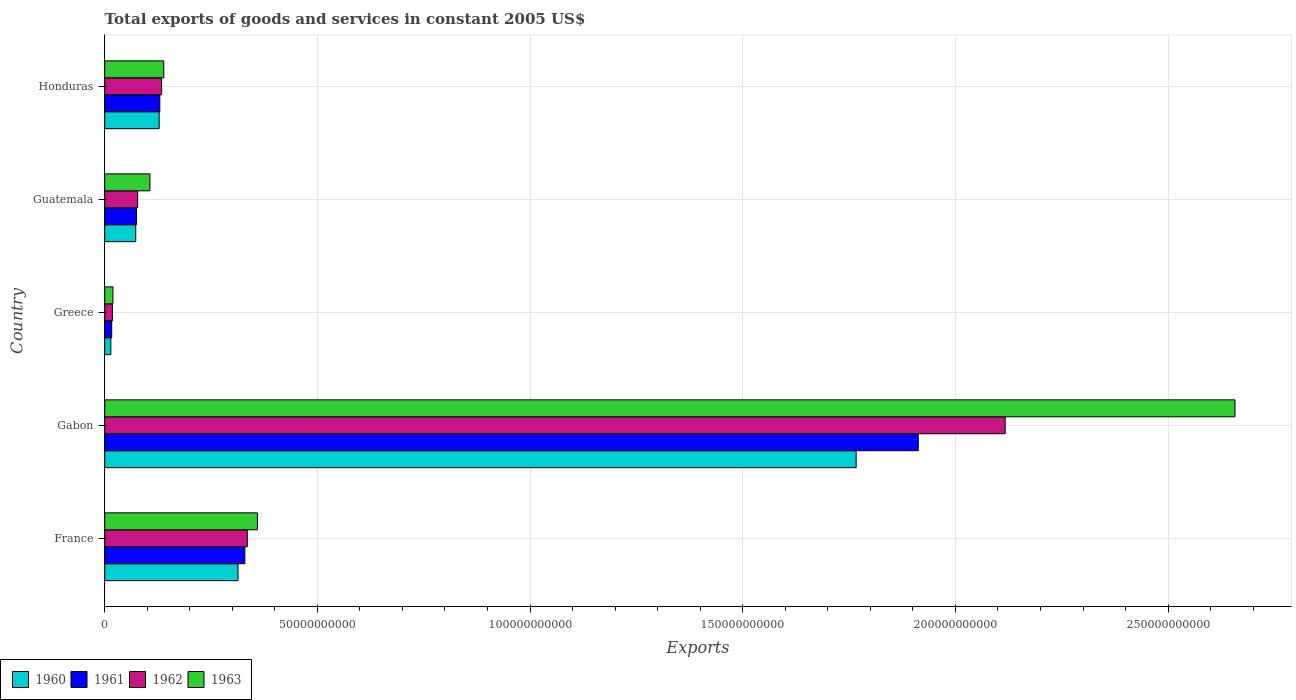Are the number of bars per tick equal to the number of legend labels?
Your response must be concise. Yes. What is the label of the 1st group of bars from the top?
Your answer should be very brief. Honduras. What is the total exports of goods and services in 1961 in France?
Keep it short and to the point. 3.29e+1. Across all countries, what is the maximum total exports of goods and services in 1960?
Offer a very short reply. 1.77e+11. Across all countries, what is the minimum total exports of goods and services in 1962?
Give a very brief answer. 1.81e+09. In which country was the total exports of goods and services in 1963 maximum?
Your answer should be compact. Gabon. What is the total total exports of goods and services in 1962 in the graph?
Provide a short and direct response. 2.68e+11. What is the difference between the total exports of goods and services in 1962 in Greece and that in Guatemala?
Your response must be concise. -5.94e+09. What is the difference between the total exports of goods and services in 1960 in Guatemala and the total exports of goods and services in 1961 in Gabon?
Offer a terse response. -1.84e+11. What is the average total exports of goods and services in 1962 per country?
Your response must be concise. 5.36e+1. What is the difference between the total exports of goods and services in 1962 and total exports of goods and services in 1960 in France?
Provide a short and direct response. 2.19e+09. What is the ratio of the total exports of goods and services in 1963 in Guatemala to that in Honduras?
Your response must be concise. 0.76. What is the difference between the highest and the second highest total exports of goods and services in 1960?
Ensure brevity in your answer.  1.45e+11. What is the difference between the highest and the lowest total exports of goods and services in 1961?
Your answer should be compact. 1.90e+11. In how many countries, is the total exports of goods and services in 1962 greater than the average total exports of goods and services in 1962 taken over all countries?
Offer a very short reply. 1. Is it the case that in every country, the sum of the total exports of goods and services in 1962 and total exports of goods and services in 1963 is greater than the sum of total exports of goods and services in 1961 and total exports of goods and services in 1960?
Ensure brevity in your answer.  No. Is it the case that in every country, the sum of the total exports of goods and services in 1961 and total exports of goods and services in 1963 is greater than the total exports of goods and services in 1960?
Provide a short and direct response. Yes. How many bars are there?
Offer a terse response. 20. Are all the bars in the graph horizontal?
Your answer should be compact. Yes. How many countries are there in the graph?
Provide a succinct answer. 5. What is the difference between two consecutive major ticks on the X-axis?
Make the answer very short. 5.00e+1. Are the values on the major ticks of X-axis written in scientific E-notation?
Your answer should be very brief. No. Does the graph contain grids?
Ensure brevity in your answer.  Yes. How are the legend labels stacked?
Your response must be concise. Horizontal. What is the title of the graph?
Your answer should be compact. Total exports of goods and services in constant 2005 US$. What is the label or title of the X-axis?
Your answer should be very brief. Exports. What is the label or title of the Y-axis?
Give a very brief answer. Country. What is the Exports of 1960 in France?
Ensure brevity in your answer.  3.13e+1. What is the Exports of 1961 in France?
Offer a terse response. 3.29e+1. What is the Exports in 1962 in France?
Provide a succinct answer. 3.35e+1. What is the Exports of 1963 in France?
Your response must be concise. 3.59e+1. What is the Exports in 1960 in Gabon?
Offer a very short reply. 1.77e+11. What is the Exports of 1961 in Gabon?
Ensure brevity in your answer.  1.91e+11. What is the Exports in 1962 in Gabon?
Your response must be concise. 2.12e+11. What is the Exports in 1963 in Gabon?
Your response must be concise. 2.66e+11. What is the Exports in 1960 in Greece?
Ensure brevity in your answer.  1.43e+09. What is the Exports in 1961 in Greece?
Provide a short and direct response. 1.64e+09. What is the Exports of 1962 in Greece?
Give a very brief answer. 1.81e+09. What is the Exports of 1963 in Greece?
Provide a succinct answer. 1.93e+09. What is the Exports in 1960 in Guatemala?
Your response must be concise. 7.29e+09. What is the Exports of 1961 in Guatemala?
Make the answer very short. 7.46e+09. What is the Exports of 1962 in Guatemala?
Provide a short and direct response. 7.75e+09. What is the Exports in 1963 in Guatemala?
Provide a succinct answer. 1.06e+1. What is the Exports in 1960 in Honduras?
Offer a very short reply. 1.28e+1. What is the Exports of 1961 in Honduras?
Your answer should be very brief. 1.30e+1. What is the Exports of 1962 in Honduras?
Make the answer very short. 1.34e+1. What is the Exports in 1963 in Honduras?
Your response must be concise. 1.39e+1. Across all countries, what is the maximum Exports of 1960?
Your answer should be compact. 1.77e+11. Across all countries, what is the maximum Exports in 1961?
Offer a very short reply. 1.91e+11. Across all countries, what is the maximum Exports in 1962?
Your response must be concise. 2.12e+11. Across all countries, what is the maximum Exports in 1963?
Provide a succinct answer. 2.66e+11. Across all countries, what is the minimum Exports of 1960?
Offer a terse response. 1.43e+09. Across all countries, what is the minimum Exports of 1961?
Provide a succinct answer. 1.64e+09. Across all countries, what is the minimum Exports in 1962?
Give a very brief answer. 1.81e+09. Across all countries, what is the minimum Exports in 1963?
Offer a very short reply. 1.93e+09. What is the total Exports in 1960 in the graph?
Keep it short and to the point. 2.30e+11. What is the total Exports of 1961 in the graph?
Your answer should be very brief. 2.46e+11. What is the total Exports of 1962 in the graph?
Your answer should be compact. 2.68e+11. What is the total Exports of 1963 in the graph?
Offer a terse response. 3.28e+11. What is the difference between the Exports in 1960 in France and that in Gabon?
Make the answer very short. -1.45e+11. What is the difference between the Exports in 1961 in France and that in Gabon?
Keep it short and to the point. -1.58e+11. What is the difference between the Exports of 1962 in France and that in Gabon?
Offer a terse response. -1.78e+11. What is the difference between the Exports in 1963 in France and that in Gabon?
Make the answer very short. -2.30e+11. What is the difference between the Exports of 1960 in France and that in Greece?
Provide a succinct answer. 2.99e+1. What is the difference between the Exports in 1961 in France and that in Greece?
Make the answer very short. 3.13e+1. What is the difference between the Exports in 1962 in France and that in Greece?
Provide a short and direct response. 3.17e+1. What is the difference between the Exports in 1963 in France and that in Greece?
Provide a short and direct response. 3.40e+1. What is the difference between the Exports in 1960 in France and that in Guatemala?
Provide a succinct answer. 2.40e+1. What is the difference between the Exports in 1961 in France and that in Guatemala?
Make the answer very short. 2.55e+1. What is the difference between the Exports in 1962 in France and that in Guatemala?
Offer a terse response. 2.58e+1. What is the difference between the Exports in 1963 in France and that in Guatemala?
Provide a short and direct response. 2.53e+1. What is the difference between the Exports in 1960 in France and that in Honduras?
Your response must be concise. 1.85e+1. What is the difference between the Exports in 1961 in France and that in Honduras?
Ensure brevity in your answer.  2.00e+1. What is the difference between the Exports of 1962 in France and that in Honduras?
Provide a short and direct response. 2.01e+1. What is the difference between the Exports of 1963 in France and that in Honduras?
Your answer should be very brief. 2.20e+1. What is the difference between the Exports of 1960 in Gabon and that in Greece?
Your answer should be very brief. 1.75e+11. What is the difference between the Exports of 1961 in Gabon and that in Greece?
Offer a terse response. 1.90e+11. What is the difference between the Exports in 1962 in Gabon and that in Greece?
Your answer should be very brief. 2.10e+11. What is the difference between the Exports in 1963 in Gabon and that in Greece?
Offer a terse response. 2.64e+11. What is the difference between the Exports of 1960 in Gabon and that in Guatemala?
Make the answer very short. 1.69e+11. What is the difference between the Exports in 1961 in Gabon and that in Guatemala?
Give a very brief answer. 1.84e+11. What is the difference between the Exports of 1962 in Gabon and that in Guatemala?
Your answer should be compact. 2.04e+11. What is the difference between the Exports of 1963 in Gabon and that in Guatemala?
Offer a terse response. 2.55e+11. What is the difference between the Exports of 1960 in Gabon and that in Honduras?
Make the answer very short. 1.64e+11. What is the difference between the Exports of 1961 in Gabon and that in Honduras?
Give a very brief answer. 1.78e+11. What is the difference between the Exports of 1962 in Gabon and that in Honduras?
Give a very brief answer. 1.98e+11. What is the difference between the Exports of 1963 in Gabon and that in Honduras?
Give a very brief answer. 2.52e+11. What is the difference between the Exports of 1960 in Greece and that in Guatemala?
Your answer should be very brief. -5.85e+09. What is the difference between the Exports in 1961 in Greece and that in Guatemala?
Provide a short and direct response. -5.82e+09. What is the difference between the Exports of 1962 in Greece and that in Guatemala?
Offer a terse response. -5.94e+09. What is the difference between the Exports in 1963 in Greece and that in Guatemala?
Your answer should be compact. -8.70e+09. What is the difference between the Exports of 1960 in Greece and that in Honduras?
Provide a succinct answer. -1.14e+1. What is the difference between the Exports in 1961 in Greece and that in Honduras?
Keep it short and to the point. -1.13e+1. What is the difference between the Exports of 1962 in Greece and that in Honduras?
Offer a very short reply. -1.16e+1. What is the difference between the Exports of 1963 in Greece and that in Honduras?
Keep it short and to the point. -1.20e+1. What is the difference between the Exports of 1960 in Guatemala and that in Honduras?
Provide a short and direct response. -5.51e+09. What is the difference between the Exports of 1961 in Guatemala and that in Honduras?
Your answer should be compact. -5.49e+09. What is the difference between the Exports of 1962 in Guatemala and that in Honduras?
Your response must be concise. -5.63e+09. What is the difference between the Exports in 1963 in Guatemala and that in Honduras?
Keep it short and to the point. -3.26e+09. What is the difference between the Exports in 1960 in France and the Exports in 1961 in Gabon?
Offer a very short reply. -1.60e+11. What is the difference between the Exports of 1960 in France and the Exports of 1962 in Gabon?
Provide a short and direct response. -1.80e+11. What is the difference between the Exports in 1960 in France and the Exports in 1963 in Gabon?
Provide a short and direct response. -2.34e+11. What is the difference between the Exports of 1961 in France and the Exports of 1962 in Gabon?
Make the answer very short. -1.79e+11. What is the difference between the Exports of 1961 in France and the Exports of 1963 in Gabon?
Keep it short and to the point. -2.33e+11. What is the difference between the Exports of 1962 in France and the Exports of 1963 in Gabon?
Provide a short and direct response. -2.32e+11. What is the difference between the Exports in 1960 in France and the Exports in 1961 in Greece?
Offer a terse response. 2.97e+1. What is the difference between the Exports in 1960 in France and the Exports in 1962 in Greece?
Offer a terse response. 2.95e+1. What is the difference between the Exports in 1960 in France and the Exports in 1963 in Greece?
Ensure brevity in your answer.  2.94e+1. What is the difference between the Exports in 1961 in France and the Exports in 1962 in Greece?
Give a very brief answer. 3.11e+1. What is the difference between the Exports in 1961 in France and the Exports in 1963 in Greece?
Provide a succinct answer. 3.10e+1. What is the difference between the Exports of 1962 in France and the Exports of 1963 in Greece?
Your answer should be compact. 3.16e+1. What is the difference between the Exports of 1960 in France and the Exports of 1961 in Guatemala?
Your response must be concise. 2.39e+1. What is the difference between the Exports in 1960 in France and the Exports in 1962 in Guatemala?
Keep it short and to the point. 2.36e+1. What is the difference between the Exports in 1960 in France and the Exports in 1963 in Guatemala?
Ensure brevity in your answer.  2.07e+1. What is the difference between the Exports of 1961 in France and the Exports of 1962 in Guatemala?
Keep it short and to the point. 2.52e+1. What is the difference between the Exports in 1961 in France and the Exports in 1963 in Guatemala?
Offer a terse response. 2.23e+1. What is the difference between the Exports in 1962 in France and the Exports in 1963 in Guatemala?
Your response must be concise. 2.29e+1. What is the difference between the Exports of 1960 in France and the Exports of 1961 in Honduras?
Offer a very short reply. 1.84e+1. What is the difference between the Exports in 1960 in France and the Exports in 1962 in Honduras?
Ensure brevity in your answer.  1.80e+1. What is the difference between the Exports of 1960 in France and the Exports of 1963 in Honduras?
Give a very brief answer. 1.74e+1. What is the difference between the Exports of 1961 in France and the Exports of 1962 in Honduras?
Provide a short and direct response. 1.96e+1. What is the difference between the Exports of 1961 in France and the Exports of 1963 in Honduras?
Your answer should be very brief. 1.91e+1. What is the difference between the Exports of 1962 in France and the Exports of 1963 in Honduras?
Ensure brevity in your answer.  1.96e+1. What is the difference between the Exports in 1960 in Gabon and the Exports in 1961 in Greece?
Offer a very short reply. 1.75e+11. What is the difference between the Exports in 1960 in Gabon and the Exports in 1962 in Greece?
Make the answer very short. 1.75e+11. What is the difference between the Exports of 1960 in Gabon and the Exports of 1963 in Greece?
Offer a terse response. 1.75e+11. What is the difference between the Exports of 1961 in Gabon and the Exports of 1962 in Greece?
Offer a terse response. 1.89e+11. What is the difference between the Exports of 1961 in Gabon and the Exports of 1963 in Greece?
Keep it short and to the point. 1.89e+11. What is the difference between the Exports of 1962 in Gabon and the Exports of 1963 in Greece?
Keep it short and to the point. 2.10e+11. What is the difference between the Exports of 1960 in Gabon and the Exports of 1961 in Guatemala?
Offer a very short reply. 1.69e+11. What is the difference between the Exports of 1960 in Gabon and the Exports of 1962 in Guatemala?
Make the answer very short. 1.69e+11. What is the difference between the Exports in 1960 in Gabon and the Exports in 1963 in Guatemala?
Give a very brief answer. 1.66e+11. What is the difference between the Exports of 1961 in Gabon and the Exports of 1962 in Guatemala?
Your response must be concise. 1.84e+11. What is the difference between the Exports of 1961 in Gabon and the Exports of 1963 in Guatemala?
Provide a short and direct response. 1.81e+11. What is the difference between the Exports of 1962 in Gabon and the Exports of 1963 in Guatemala?
Give a very brief answer. 2.01e+11. What is the difference between the Exports in 1960 in Gabon and the Exports in 1961 in Honduras?
Your response must be concise. 1.64e+11. What is the difference between the Exports in 1960 in Gabon and the Exports in 1962 in Honduras?
Your response must be concise. 1.63e+11. What is the difference between the Exports of 1960 in Gabon and the Exports of 1963 in Honduras?
Your response must be concise. 1.63e+11. What is the difference between the Exports of 1961 in Gabon and the Exports of 1962 in Honduras?
Ensure brevity in your answer.  1.78e+11. What is the difference between the Exports in 1961 in Gabon and the Exports in 1963 in Honduras?
Make the answer very short. 1.77e+11. What is the difference between the Exports of 1962 in Gabon and the Exports of 1963 in Honduras?
Ensure brevity in your answer.  1.98e+11. What is the difference between the Exports in 1960 in Greece and the Exports in 1961 in Guatemala?
Offer a very short reply. -6.02e+09. What is the difference between the Exports in 1960 in Greece and the Exports in 1962 in Guatemala?
Provide a succinct answer. -6.31e+09. What is the difference between the Exports of 1960 in Greece and the Exports of 1963 in Guatemala?
Make the answer very short. -9.19e+09. What is the difference between the Exports in 1961 in Greece and the Exports in 1962 in Guatemala?
Ensure brevity in your answer.  -6.10e+09. What is the difference between the Exports in 1961 in Greece and the Exports in 1963 in Guatemala?
Offer a terse response. -8.98e+09. What is the difference between the Exports in 1962 in Greece and the Exports in 1963 in Guatemala?
Your answer should be very brief. -8.82e+09. What is the difference between the Exports of 1960 in Greece and the Exports of 1961 in Honduras?
Provide a short and direct response. -1.15e+1. What is the difference between the Exports in 1960 in Greece and the Exports in 1962 in Honduras?
Offer a very short reply. -1.19e+1. What is the difference between the Exports of 1960 in Greece and the Exports of 1963 in Honduras?
Give a very brief answer. -1.25e+1. What is the difference between the Exports in 1961 in Greece and the Exports in 1962 in Honduras?
Your response must be concise. -1.17e+1. What is the difference between the Exports of 1961 in Greece and the Exports of 1963 in Honduras?
Provide a short and direct response. -1.22e+1. What is the difference between the Exports of 1962 in Greece and the Exports of 1963 in Honduras?
Provide a short and direct response. -1.21e+1. What is the difference between the Exports of 1960 in Guatemala and the Exports of 1961 in Honduras?
Ensure brevity in your answer.  -5.66e+09. What is the difference between the Exports in 1960 in Guatemala and the Exports in 1962 in Honduras?
Give a very brief answer. -6.09e+09. What is the difference between the Exports in 1960 in Guatemala and the Exports in 1963 in Honduras?
Keep it short and to the point. -6.60e+09. What is the difference between the Exports of 1961 in Guatemala and the Exports of 1962 in Honduras?
Your answer should be very brief. -5.92e+09. What is the difference between the Exports in 1961 in Guatemala and the Exports in 1963 in Honduras?
Your answer should be compact. -6.43e+09. What is the difference between the Exports of 1962 in Guatemala and the Exports of 1963 in Honduras?
Give a very brief answer. -6.14e+09. What is the average Exports in 1960 per country?
Make the answer very short. 4.59e+1. What is the average Exports of 1961 per country?
Provide a short and direct response. 4.93e+1. What is the average Exports of 1962 per country?
Provide a short and direct response. 5.36e+1. What is the average Exports in 1963 per country?
Offer a very short reply. 6.56e+1. What is the difference between the Exports in 1960 and Exports in 1961 in France?
Provide a short and direct response. -1.60e+09. What is the difference between the Exports in 1960 and Exports in 1962 in France?
Your answer should be very brief. -2.19e+09. What is the difference between the Exports of 1960 and Exports of 1963 in France?
Your answer should be compact. -4.55e+09. What is the difference between the Exports in 1961 and Exports in 1962 in France?
Your response must be concise. -5.82e+08. What is the difference between the Exports of 1961 and Exports of 1963 in France?
Give a very brief answer. -2.95e+09. What is the difference between the Exports in 1962 and Exports in 1963 in France?
Keep it short and to the point. -2.37e+09. What is the difference between the Exports in 1960 and Exports in 1961 in Gabon?
Offer a terse response. -1.46e+1. What is the difference between the Exports of 1960 and Exports of 1962 in Gabon?
Your response must be concise. -3.50e+1. What is the difference between the Exports of 1960 and Exports of 1963 in Gabon?
Ensure brevity in your answer.  -8.91e+1. What is the difference between the Exports in 1961 and Exports in 1962 in Gabon?
Offer a very short reply. -2.04e+1. What is the difference between the Exports in 1961 and Exports in 1963 in Gabon?
Keep it short and to the point. -7.45e+1. What is the difference between the Exports in 1962 and Exports in 1963 in Gabon?
Offer a very short reply. -5.40e+1. What is the difference between the Exports of 1960 and Exports of 1961 in Greece?
Your response must be concise. -2.08e+08. What is the difference between the Exports of 1960 and Exports of 1962 in Greece?
Make the answer very short. -3.72e+08. What is the difference between the Exports of 1960 and Exports of 1963 in Greece?
Offer a very short reply. -4.92e+08. What is the difference between the Exports in 1961 and Exports in 1962 in Greece?
Provide a short and direct response. -1.64e+08. What is the difference between the Exports in 1961 and Exports in 1963 in Greece?
Your answer should be very brief. -2.84e+08. What is the difference between the Exports in 1962 and Exports in 1963 in Greece?
Give a very brief answer. -1.20e+08. What is the difference between the Exports of 1960 and Exports of 1961 in Guatemala?
Offer a very short reply. -1.71e+08. What is the difference between the Exports in 1960 and Exports in 1962 in Guatemala?
Make the answer very short. -4.57e+08. What is the difference between the Exports in 1960 and Exports in 1963 in Guatemala?
Your answer should be very brief. -3.33e+09. What is the difference between the Exports of 1961 and Exports of 1962 in Guatemala?
Your answer should be compact. -2.86e+08. What is the difference between the Exports in 1961 and Exports in 1963 in Guatemala?
Offer a very short reply. -3.16e+09. What is the difference between the Exports of 1962 and Exports of 1963 in Guatemala?
Provide a short and direct response. -2.88e+09. What is the difference between the Exports in 1960 and Exports in 1961 in Honduras?
Provide a short and direct response. -1.52e+08. What is the difference between the Exports of 1960 and Exports of 1962 in Honduras?
Make the answer very short. -5.74e+08. What is the difference between the Exports of 1960 and Exports of 1963 in Honduras?
Ensure brevity in your answer.  -1.09e+09. What is the difference between the Exports in 1961 and Exports in 1962 in Honduras?
Your answer should be compact. -4.22e+08. What is the difference between the Exports in 1961 and Exports in 1963 in Honduras?
Provide a short and direct response. -9.34e+08. What is the difference between the Exports in 1962 and Exports in 1963 in Honduras?
Provide a succinct answer. -5.12e+08. What is the ratio of the Exports of 1960 in France to that in Gabon?
Make the answer very short. 0.18. What is the ratio of the Exports in 1961 in France to that in Gabon?
Offer a terse response. 0.17. What is the ratio of the Exports in 1962 in France to that in Gabon?
Your response must be concise. 0.16. What is the ratio of the Exports in 1963 in France to that in Gabon?
Your answer should be compact. 0.14. What is the ratio of the Exports of 1960 in France to that in Greece?
Ensure brevity in your answer.  21.84. What is the ratio of the Exports in 1961 in France to that in Greece?
Give a very brief answer. 20.05. What is the ratio of the Exports of 1962 in France to that in Greece?
Offer a terse response. 18.55. What is the ratio of the Exports in 1963 in France to that in Greece?
Ensure brevity in your answer.  18.62. What is the ratio of the Exports in 1960 in France to that in Guatemala?
Your answer should be compact. 4.3. What is the ratio of the Exports in 1961 in France to that in Guatemala?
Offer a terse response. 4.42. What is the ratio of the Exports in 1962 in France to that in Guatemala?
Offer a terse response. 4.33. What is the ratio of the Exports of 1963 in France to that in Guatemala?
Your answer should be very brief. 3.38. What is the ratio of the Exports of 1960 in France to that in Honduras?
Keep it short and to the point. 2.45. What is the ratio of the Exports of 1961 in France to that in Honduras?
Provide a succinct answer. 2.54. What is the ratio of the Exports in 1962 in France to that in Honduras?
Your response must be concise. 2.51. What is the ratio of the Exports of 1963 in France to that in Honduras?
Keep it short and to the point. 2.58. What is the ratio of the Exports of 1960 in Gabon to that in Greece?
Your answer should be very brief. 123.12. What is the ratio of the Exports of 1961 in Gabon to that in Greece?
Your response must be concise. 116.39. What is the ratio of the Exports of 1962 in Gabon to that in Greece?
Provide a succinct answer. 117.16. What is the ratio of the Exports of 1963 in Gabon to that in Greece?
Give a very brief answer. 137.87. What is the ratio of the Exports of 1960 in Gabon to that in Guatemala?
Your answer should be very brief. 24.24. What is the ratio of the Exports in 1961 in Gabon to that in Guatemala?
Your answer should be very brief. 25.64. What is the ratio of the Exports of 1962 in Gabon to that in Guatemala?
Your answer should be compact. 27.33. What is the ratio of the Exports of 1963 in Gabon to that in Guatemala?
Keep it short and to the point. 25.02. What is the ratio of the Exports of 1960 in Gabon to that in Honduras?
Your answer should be compact. 13.8. What is the ratio of the Exports of 1961 in Gabon to that in Honduras?
Give a very brief answer. 14.77. What is the ratio of the Exports in 1962 in Gabon to that in Honduras?
Your response must be concise. 15.83. What is the ratio of the Exports in 1963 in Gabon to that in Honduras?
Your answer should be very brief. 19.14. What is the ratio of the Exports of 1960 in Greece to that in Guatemala?
Provide a short and direct response. 0.2. What is the ratio of the Exports of 1961 in Greece to that in Guatemala?
Your answer should be compact. 0.22. What is the ratio of the Exports of 1962 in Greece to that in Guatemala?
Provide a short and direct response. 0.23. What is the ratio of the Exports in 1963 in Greece to that in Guatemala?
Ensure brevity in your answer.  0.18. What is the ratio of the Exports in 1960 in Greece to that in Honduras?
Keep it short and to the point. 0.11. What is the ratio of the Exports in 1961 in Greece to that in Honduras?
Provide a succinct answer. 0.13. What is the ratio of the Exports of 1962 in Greece to that in Honduras?
Provide a short and direct response. 0.14. What is the ratio of the Exports of 1963 in Greece to that in Honduras?
Offer a very short reply. 0.14. What is the ratio of the Exports of 1960 in Guatemala to that in Honduras?
Offer a terse response. 0.57. What is the ratio of the Exports in 1961 in Guatemala to that in Honduras?
Provide a short and direct response. 0.58. What is the ratio of the Exports of 1962 in Guatemala to that in Honduras?
Your answer should be compact. 0.58. What is the ratio of the Exports in 1963 in Guatemala to that in Honduras?
Ensure brevity in your answer.  0.76. What is the difference between the highest and the second highest Exports in 1960?
Offer a very short reply. 1.45e+11. What is the difference between the highest and the second highest Exports in 1961?
Ensure brevity in your answer.  1.58e+11. What is the difference between the highest and the second highest Exports of 1962?
Your response must be concise. 1.78e+11. What is the difference between the highest and the second highest Exports in 1963?
Offer a terse response. 2.30e+11. What is the difference between the highest and the lowest Exports of 1960?
Make the answer very short. 1.75e+11. What is the difference between the highest and the lowest Exports of 1961?
Give a very brief answer. 1.90e+11. What is the difference between the highest and the lowest Exports in 1962?
Keep it short and to the point. 2.10e+11. What is the difference between the highest and the lowest Exports of 1963?
Your answer should be very brief. 2.64e+11. 